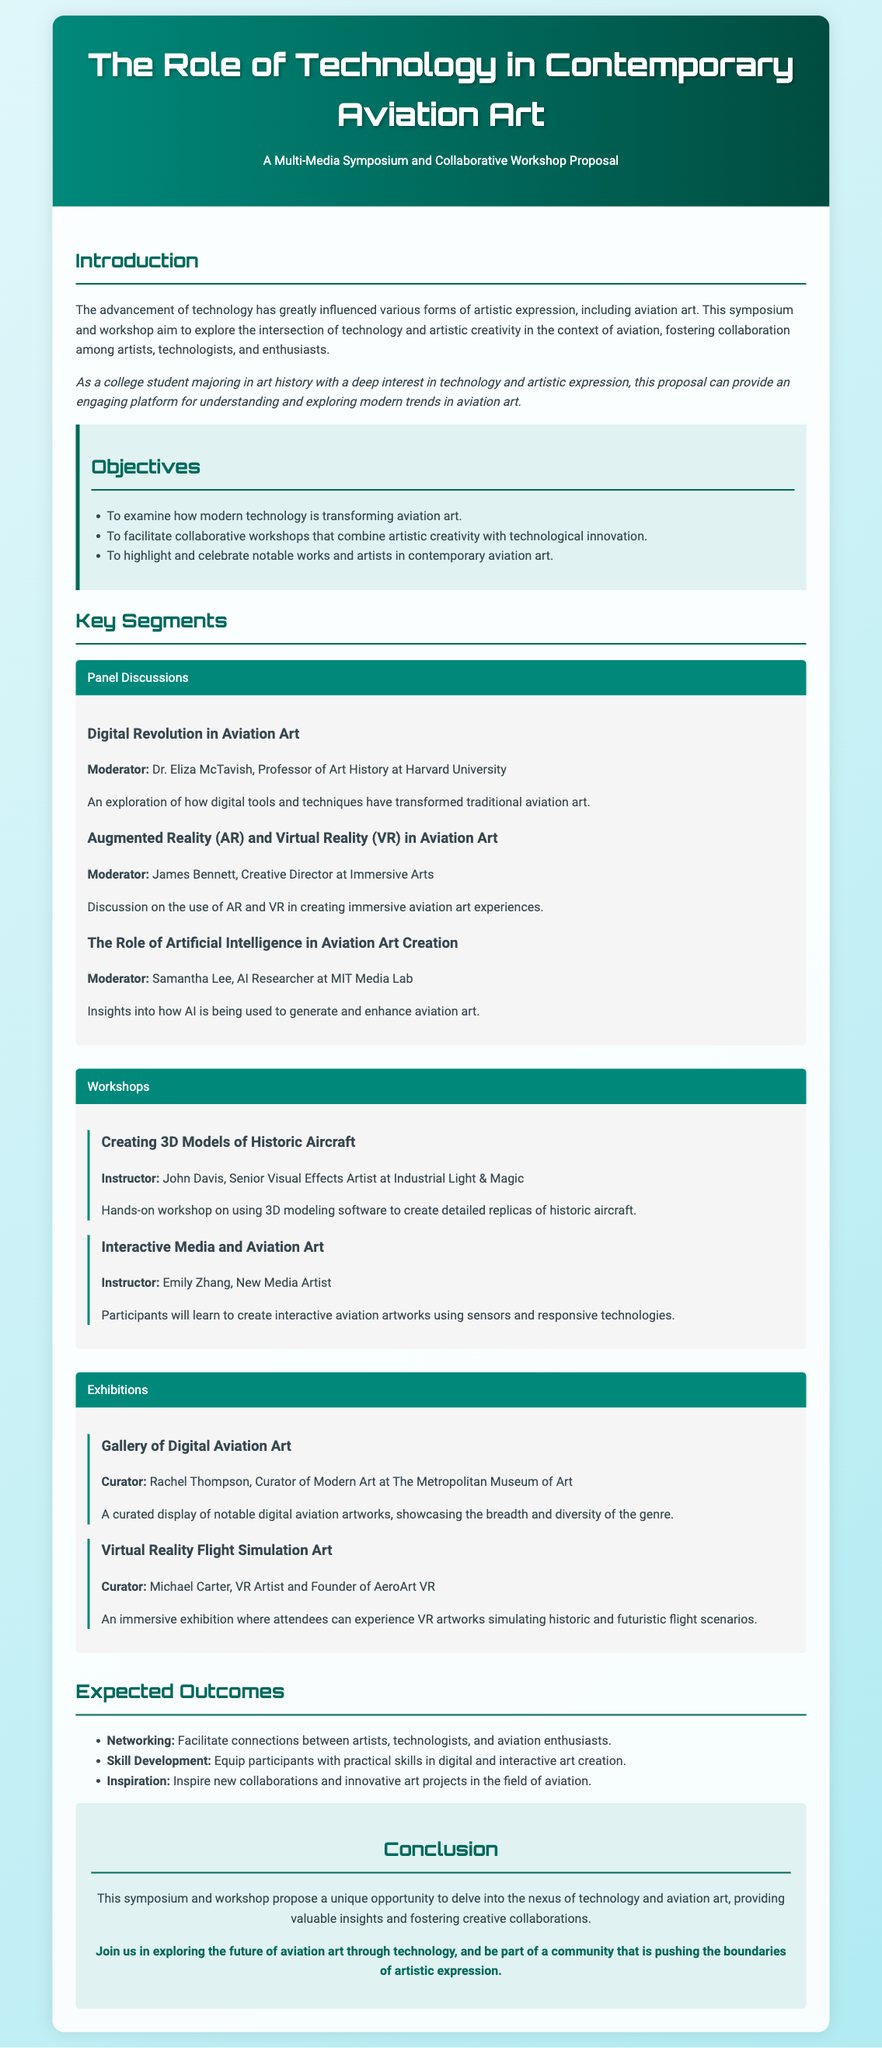What is the title of the proposal? The title appears at the top of the document and is "The Role of Technology in Contemporary Aviation Art".
Answer: The Role of Technology in Contemporary Aviation Art Who is the moderator for the panel discussion on Augmented Reality and Virtual Reality in Aviation Art? The moderator's name is provided along with the discussion topic. The name is James Bennett.
Answer: James Bennett What is one of the objectives of the symposium? The document lists several objectives, one being to examine how modern technology is transforming aviation art.
Answer: To examine how modern technology is transforming aviation art How many workshops are mentioned in the proposal? The proposal lists two specific workshops under the workshops segment.
Answer: Two Who is the curator for the Gallery of Digital Aviation Art? The name of the curator is specified in the exhibitions section of the document. The curator is Rachel Thompson.
Answer: Rachel Thompson What is expected to inspire new collaborations according to the expected outcomes? The expected outcomes section indicates that inspiration is one of the outcomes aimed at inciting new projects.
Answer: Inspiration What field does Dr. Eliza McTavish belong to? Dr. Eliza McTavish is mentioned as a Professor in a specific field in the document.
Answer: Art History In what year was this proposal generated? The proposal content refers to trends and discussions relevant to a current context; thus, it can be inferred contextually related to 2023.
Answer: 2023 